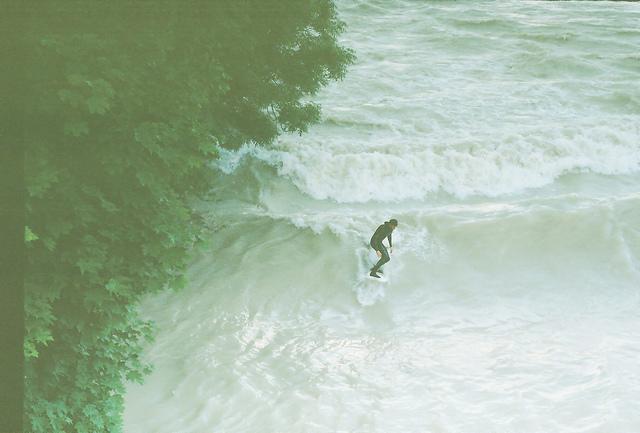How many people are on surfboards?
Give a very brief answer. 1. 